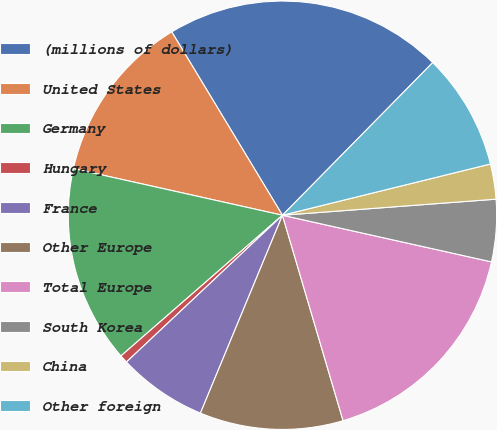<chart> <loc_0><loc_0><loc_500><loc_500><pie_chart><fcel>(millions of dollars)<fcel>United States<fcel>Germany<fcel>Hungary<fcel>France<fcel>Other Europe<fcel>Total Europe<fcel>South Korea<fcel>China<fcel>Other foreign<nl><fcel>21.02%<fcel>12.86%<fcel>14.9%<fcel>0.61%<fcel>6.73%<fcel>10.82%<fcel>16.94%<fcel>4.69%<fcel>2.65%<fcel>8.78%<nl></chart> 